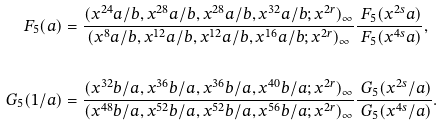<formula> <loc_0><loc_0><loc_500><loc_500>\ F _ { 5 } ( a ) & = \frac { ( x ^ { 2 4 } a / b , x ^ { 2 8 } a / b , x ^ { 2 8 } a / b , x ^ { 3 2 } a / b ; x ^ { 2 r } ) _ { \infty } } { ( x ^ { 8 } a / b , x ^ { 1 2 } a / b , x ^ { 1 2 } a / b , x ^ { 1 6 } a / b ; x ^ { 2 r } ) _ { \infty } } \frac { \ F _ { 5 } ( x ^ { 2 s } a ) } { \ F _ { 5 } ( x ^ { 4 s } a ) } , \\ & & \\ \ G _ { 5 } ( 1 / a ) & = \frac { ( x ^ { 3 2 } b / a , x ^ { 3 6 } b / a , x ^ { 3 6 } b / a , x ^ { 4 0 } b / a ; x ^ { 2 r } ) _ { \infty } } { ( x ^ { 4 8 } b / a , x ^ { 5 2 } b / a , x ^ { 5 2 } b / a , x ^ { 5 6 } b / a ; x ^ { 2 r } ) _ { \infty } } \frac { \ G _ { 5 } ( x ^ { 2 s } / a ) } { \ G _ { 5 } ( x ^ { 4 s } / a ) } .</formula> 